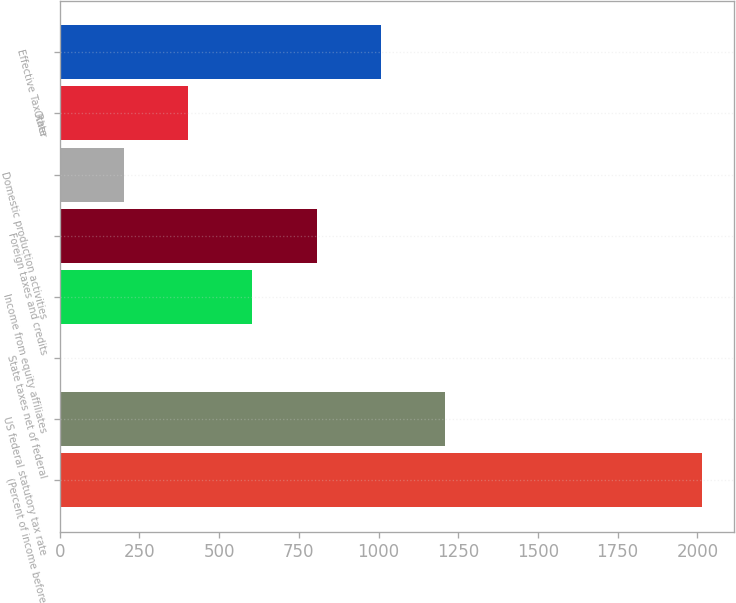Convert chart. <chart><loc_0><loc_0><loc_500><loc_500><bar_chart><fcel>(Percent of income before<fcel>US federal statutory tax rate<fcel>State taxes net of federal<fcel>Income from equity affiliates<fcel>Foreign taxes and credits<fcel>Domestic production activities<fcel>Other<fcel>Effective Tax Rate<nl><fcel>2013<fcel>1208<fcel>0.5<fcel>604.25<fcel>805.5<fcel>201.75<fcel>403<fcel>1006.75<nl></chart> 